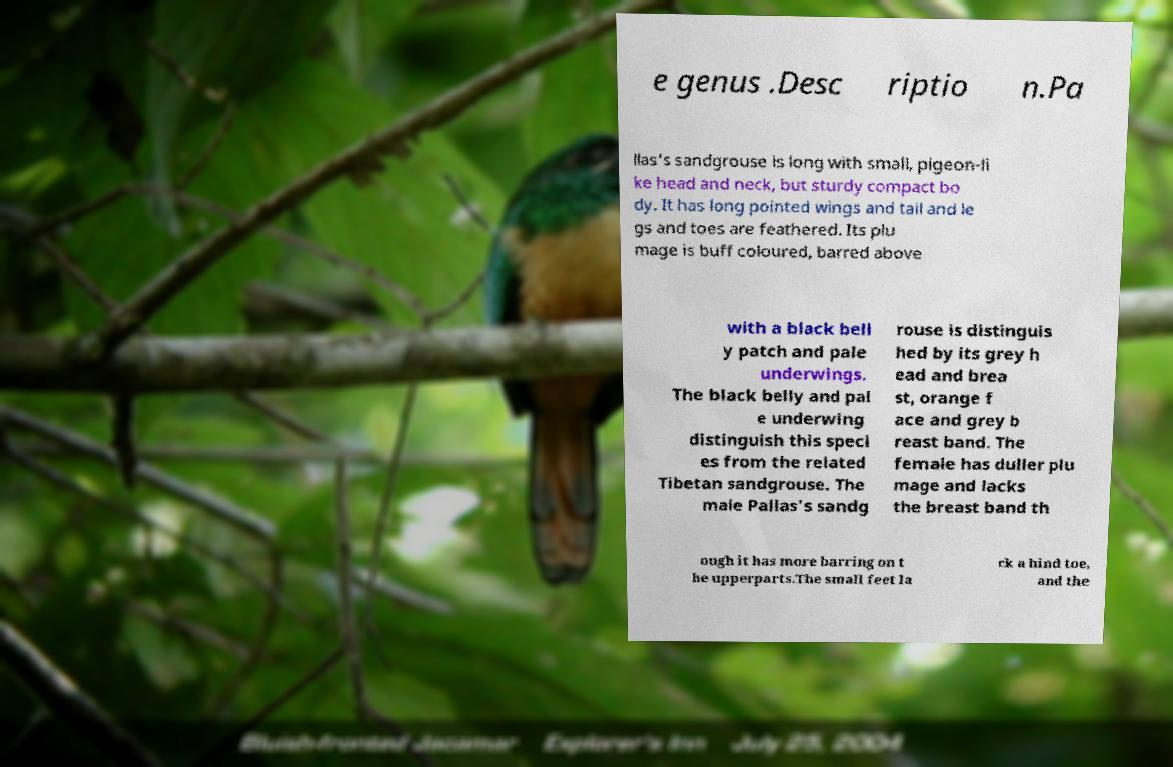What messages or text are displayed in this image? I need them in a readable, typed format. e genus .Desc riptio n.Pa llas's sandgrouse is long with small, pigeon-li ke head and neck, but sturdy compact bo dy. It has long pointed wings and tail and le gs and toes are feathered. Its plu mage is buff coloured, barred above with a black bell y patch and pale underwings. The black belly and pal e underwing distinguish this speci es from the related Tibetan sandgrouse. The male Pallas's sandg rouse is distinguis hed by its grey h ead and brea st, orange f ace and grey b reast band. The female has duller plu mage and lacks the breast band th ough it has more barring on t he upperparts.The small feet la ck a hind toe, and the 